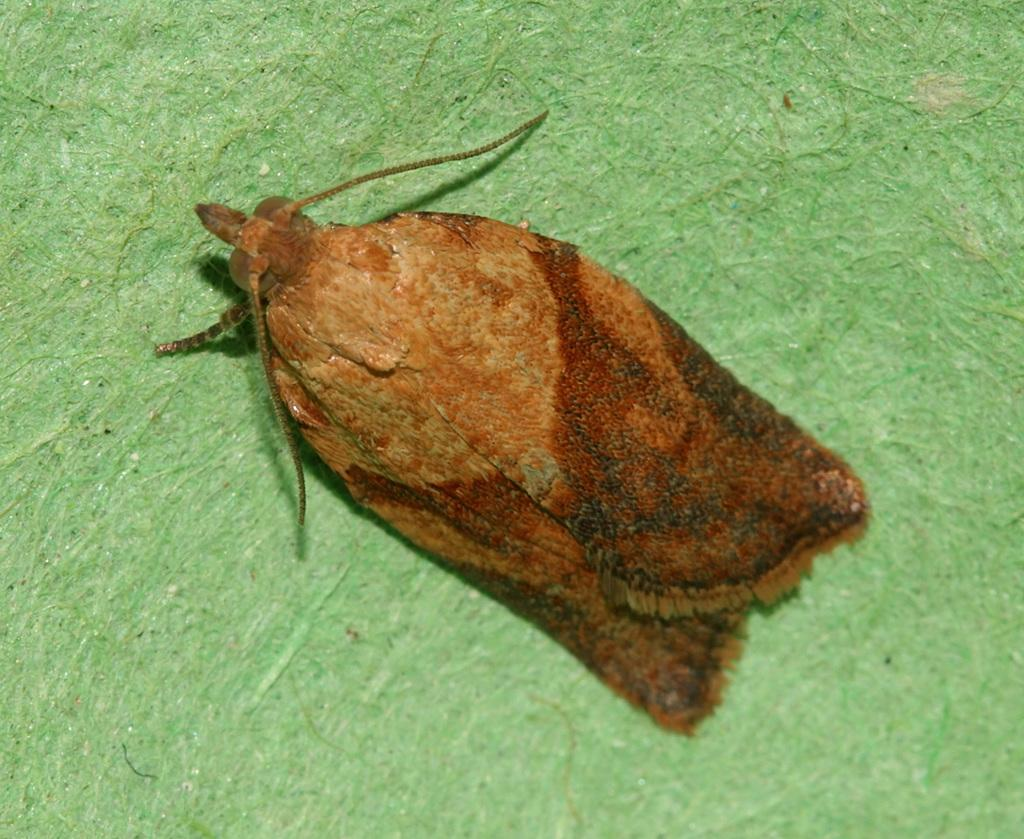What type of creature can be seen in the picture? There is an insect in the picture. What is the color of the insect? The insect is brown in color. On what surface is the insect located? The insect is on a green surface. What type of lift can be seen in the picture? There is no lift present in the picture; it features an insect on a green surface. What hope does the insect have for finding food in the picture? The picture does not provide any information about the insect's hope for finding food. 